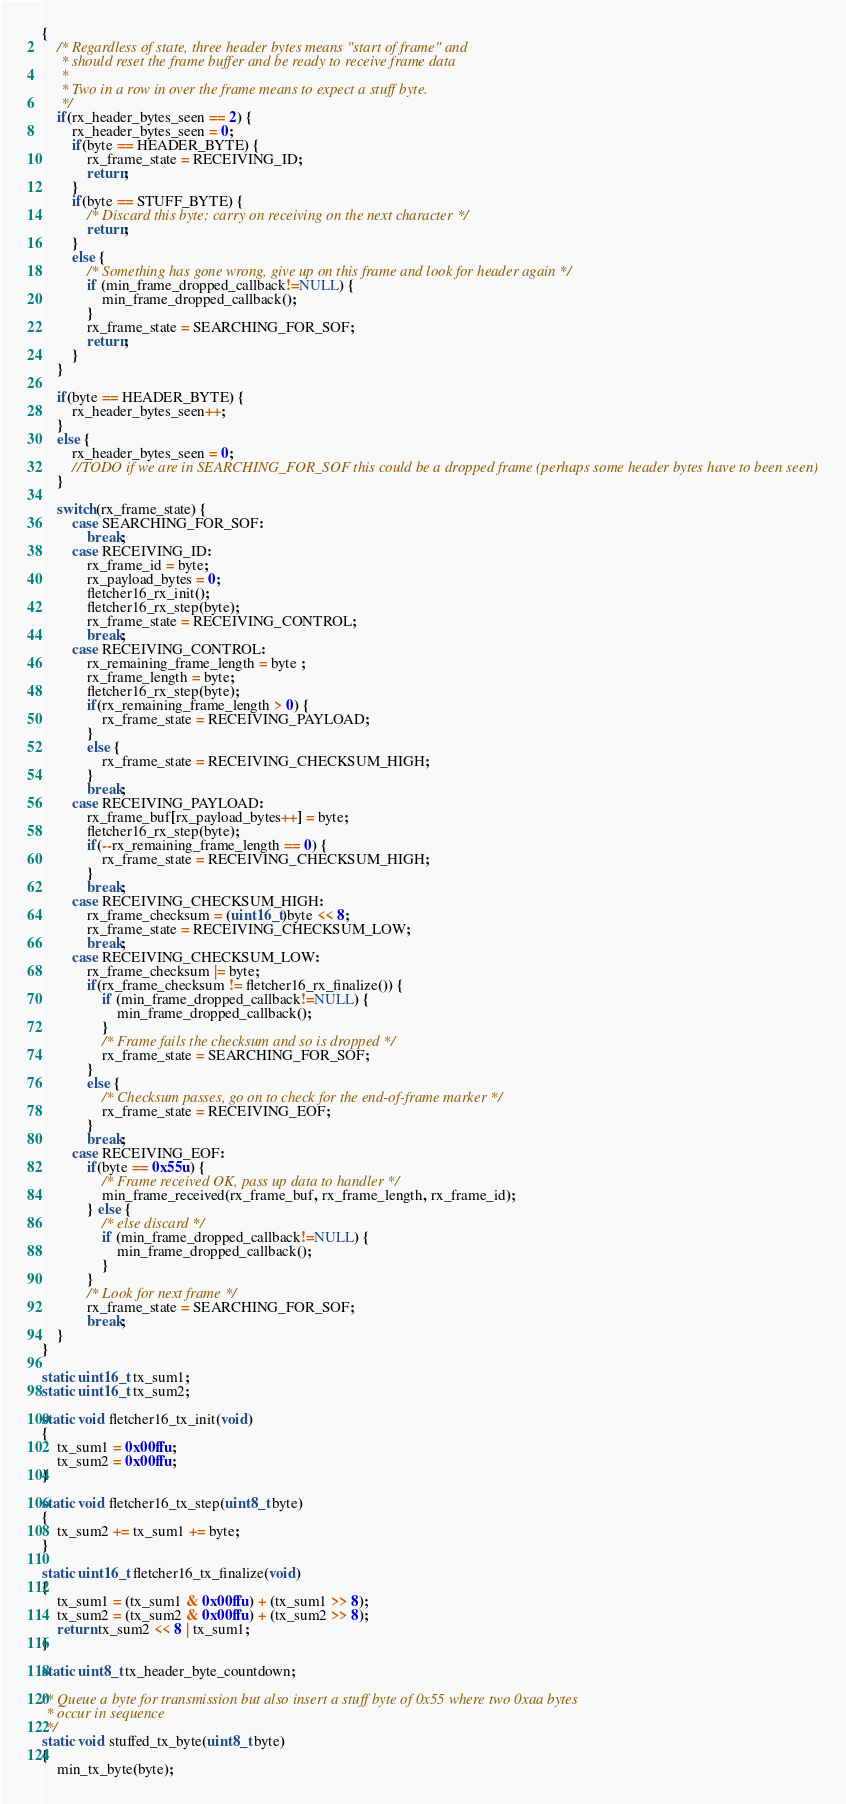<code> <loc_0><loc_0><loc_500><loc_500><_C_>{
	/* Regardless of state, three header bytes means "start of frame" and
	 * should reset the frame buffer and be ready to receive frame data
	 *
	 * Two in a row in over the frame means to expect a stuff byte.
	 */
	if(rx_header_bytes_seen == 2) {
		rx_header_bytes_seen = 0;
		if(byte == HEADER_BYTE) {
			rx_frame_state = RECEIVING_ID;
			return;
		}
		if(byte == STUFF_BYTE) {
			/* Discard this byte; carry on receiving on the next character */
			return;
		}
		else {
			/* Something has gone wrong, give up on this frame and look for header again */
			if (min_frame_dropped_callback!=NULL) {
				min_frame_dropped_callback();
		    }
			rx_frame_state = SEARCHING_FOR_SOF;
			return;
		}
	}
	
	if(byte == HEADER_BYTE) {
		rx_header_bytes_seen++;
	}
	else {
		rx_header_bytes_seen = 0;
		//TODO if we are in SEARCHING_FOR_SOF this could be a dropped frame (perhaps some header bytes have to been seen)
	}
	
	switch(rx_frame_state) {
        case SEARCHING_FOR_SOF:
            break;
        case RECEIVING_ID:
            rx_frame_id = byte;
            rx_payload_bytes = 0;
            fletcher16_rx_init();
            fletcher16_rx_step(byte);
            rx_frame_state = RECEIVING_CONTROL;
            break;
        case RECEIVING_CONTROL:
            rx_remaining_frame_length = byte ;
            rx_frame_length = byte;
            fletcher16_rx_step(byte);
            if(rx_remaining_frame_length > 0) {
                rx_frame_state = RECEIVING_PAYLOAD;
            }
            else {
                rx_frame_state = RECEIVING_CHECKSUM_HIGH;
            }
            break;
        case RECEIVING_PAYLOAD:
            rx_frame_buf[rx_payload_bytes++] = byte;
            fletcher16_rx_step(byte);
            if(--rx_remaining_frame_length == 0) {
                rx_frame_state = RECEIVING_CHECKSUM_HIGH;
            }
            break;
        case RECEIVING_CHECKSUM_HIGH:
            rx_frame_checksum = (uint16_t)byte << 8;
            rx_frame_state = RECEIVING_CHECKSUM_LOW;
            break;
        case RECEIVING_CHECKSUM_LOW:
            rx_frame_checksum |= byte;
            if(rx_frame_checksum != fletcher16_rx_finalize()) {
				if (min_frame_dropped_callback!=NULL) {
					min_frame_dropped_callback();
				}
				/* Frame fails the checksum and so is dropped */
                rx_frame_state = SEARCHING_FOR_SOF;
            }
            else {
                /* Checksum passes, go on to check for the end-of-frame marker */
                rx_frame_state = RECEIVING_EOF;
            }
            break;
        case RECEIVING_EOF:
            if(byte == 0x55u) {
                /* Frame received OK, pass up data to handler */
                min_frame_received(rx_frame_buf, rx_frame_length, rx_frame_id);
            } else {
            	/* else discard */
            	if (min_frame_dropped_callback!=NULL) {
					min_frame_dropped_callback();
				}
	        }
            /* Look for next frame */
            rx_frame_state = SEARCHING_FOR_SOF;
            break;
	}
}

static uint16_t tx_sum1;
static uint16_t tx_sum2;

static void fletcher16_tx_init(void)
{
	tx_sum1 = 0x00ffu;
	tx_sum2 = 0x00ffu;
}

static void fletcher16_tx_step(uint8_t byte)
{
	tx_sum2 += tx_sum1 += byte;
}

static uint16_t fletcher16_tx_finalize(void)
{
	tx_sum1 = (tx_sum1 & 0x00ffu) + (tx_sum1 >> 8);
	tx_sum2 = (tx_sum2 & 0x00ffu) + (tx_sum2 >> 8);
	return tx_sum2 << 8 | tx_sum1;
}

static uint8_t tx_header_byte_countdown;

/* Queue a byte for transmission but also insert a stuff byte of 0x55 where two 0xaa bytes
 * occur in sequence
 */
static void stuffed_tx_byte(uint8_t byte)
{
	min_tx_byte(byte);</code> 